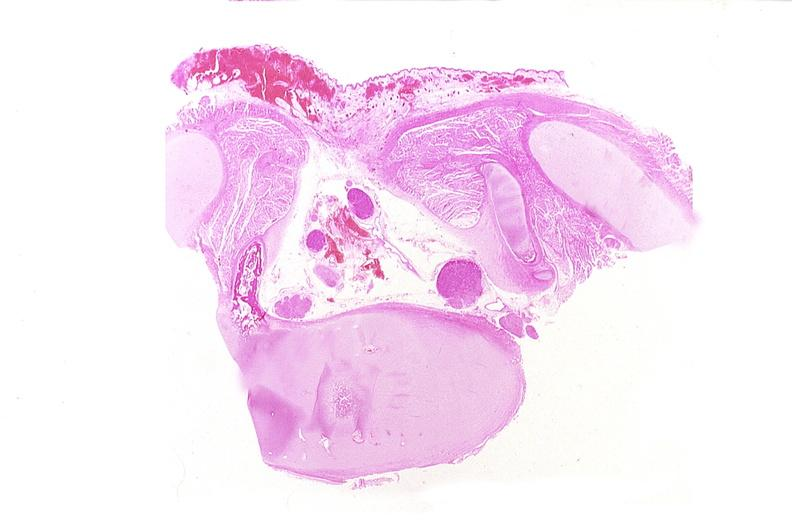s infarcts present?
Answer the question using a single word or phrase. No 